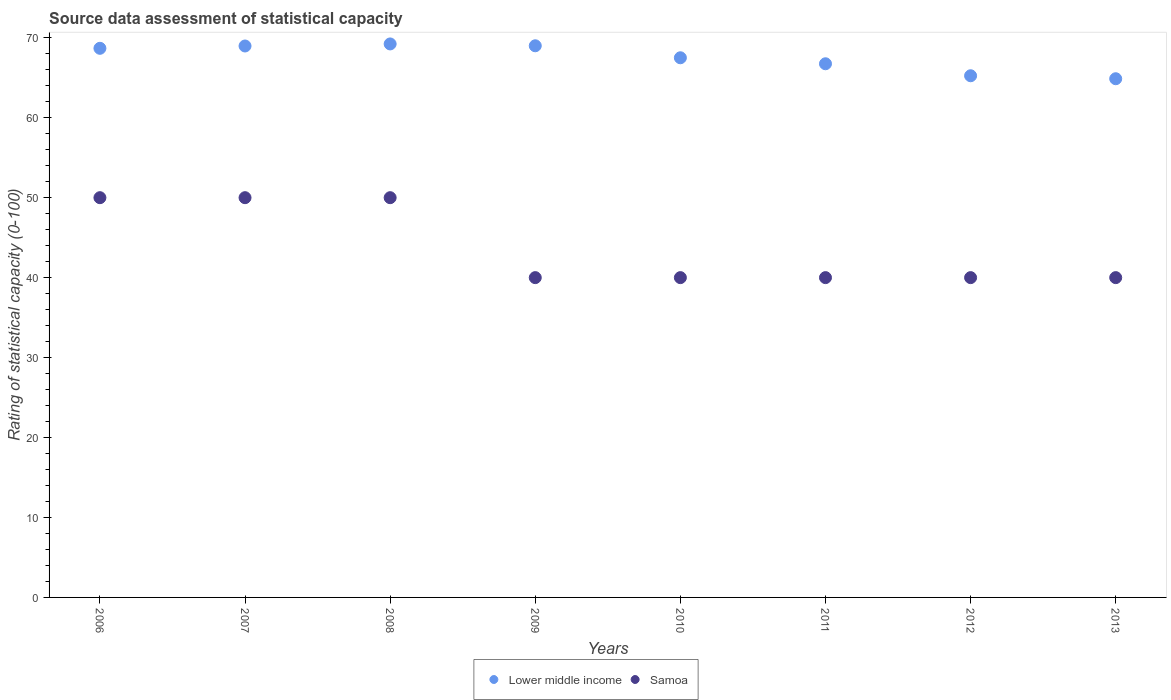Is the number of dotlines equal to the number of legend labels?
Offer a terse response. Yes. Across all years, what is the maximum rating of statistical capacity in Lower middle income?
Keep it short and to the point. 69.23. Across all years, what is the minimum rating of statistical capacity in Lower middle income?
Keep it short and to the point. 64.88. In which year was the rating of statistical capacity in Lower middle income maximum?
Provide a succinct answer. 2008. What is the total rating of statistical capacity in Lower middle income in the graph?
Ensure brevity in your answer.  540.27. What is the difference between the rating of statistical capacity in Lower middle income in 2011 and the rating of statistical capacity in Samoa in 2012?
Offer a terse response. 26.75. What is the average rating of statistical capacity in Lower middle income per year?
Give a very brief answer. 67.53. In how many years, is the rating of statistical capacity in Lower middle income greater than 46?
Give a very brief answer. 8. What is the difference between the highest and the second highest rating of statistical capacity in Lower middle income?
Provide a short and direct response. 0.23. What is the difference between the highest and the lowest rating of statistical capacity in Lower middle income?
Your answer should be very brief. 4.35. Does the rating of statistical capacity in Lower middle income monotonically increase over the years?
Your response must be concise. No. Is the rating of statistical capacity in Lower middle income strictly greater than the rating of statistical capacity in Samoa over the years?
Your answer should be compact. Yes. Is the rating of statistical capacity in Lower middle income strictly less than the rating of statistical capacity in Samoa over the years?
Make the answer very short. No. How many dotlines are there?
Make the answer very short. 2. How many years are there in the graph?
Make the answer very short. 8. What is the difference between two consecutive major ticks on the Y-axis?
Your response must be concise. 10. Are the values on the major ticks of Y-axis written in scientific E-notation?
Keep it short and to the point. No. Does the graph contain grids?
Your answer should be compact. No. How are the legend labels stacked?
Ensure brevity in your answer.  Horizontal. What is the title of the graph?
Your answer should be very brief. Source data assessment of statistical capacity. Does "Mozambique" appear as one of the legend labels in the graph?
Provide a short and direct response. No. What is the label or title of the X-axis?
Make the answer very short. Years. What is the label or title of the Y-axis?
Your answer should be compact. Rating of statistical capacity (0-100). What is the Rating of statistical capacity (0-100) of Lower middle income in 2006?
Make the answer very short. 68.68. What is the Rating of statistical capacity (0-100) of Samoa in 2006?
Provide a short and direct response. 50. What is the Rating of statistical capacity (0-100) in Lower middle income in 2007?
Ensure brevity in your answer.  68.97. What is the Rating of statistical capacity (0-100) in Samoa in 2007?
Your answer should be very brief. 50. What is the Rating of statistical capacity (0-100) in Lower middle income in 2008?
Make the answer very short. 69.23. What is the Rating of statistical capacity (0-100) in Samoa in 2008?
Give a very brief answer. 50. What is the Rating of statistical capacity (0-100) of Lower middle income in 2009?
Your response must be concise. 69. What is the Rating of statistical capacity (0-100) in Lower middle income in 2010?
Your response must be concise. 67.5. What is the Rating of statistical capacity (0-100) of Samoa in 2010?
Offer a very short reply. 40. What is the Rating of statistical capacity (0-100) in Lower middle income in 2011?
Give a very brief answer. 66.75. What is the Rating of statistical capacity (0-100) in Lower middle income in 2012?
Provide a short and direct response. 65.25. What is the Rating of statistical capacity (0-100) of Samoa in 2012?
Offer a terse response. 40. What is the Rating of statistical capacity (0-100) in Lower middle income in 2013?
Give a very brief answer. 64.88. What is the Rating of statistical capacity (0-100) of Samoa in 2013?
Provide a short and direct response. 40. Across all years, what is the maximum Rating of statistical capacity (0-100) of Lower middle income?
Give a very brief answer. 69.23. Across all years, what is the minimum Rating of statistical capacity (0-100) of Lower middle income?
Keep it short and to the point. 64.88. Across all years, what is the minimum Rating of statistical capacity (0-100) of Samoa?
Your response must be concise. 40. What is the total Rating of statistical capacity (0-100) in Lower middle income in the graph?
Give a very brief answer. 540.27. What is the total Rating of statistical capacity (0-100) in Samoa in the graph?
Keep it short and to the point. 350. What is the difference between the Rating of statistical capacity (0-100) in Lower middle income in 2006 and that in 2007?
Give a very brief answer. -0.29. What is the difference between the Rating of statistical capacity (0-100) of Samoa in 2006 and that in 2007?
Offer a terse response. 0. What is the difference between the Rating of statistical capacity (0-100) of Lower middle income in 2006 and that in 2008?
Ensure brevity in your answer.  -0.55. What is the difference between the Rating of statistical capacity (0-100) in Lower middle income in 2006 and that in 2009?
Offer a very short reply. -0.32. What is the difference between the Rating of statistical capacity (0-100) of Lower middle income in 2006 and that in 2010?
Keep it short and to the point. 1.18. What is the difference between the Rating of statistical capacity (0-100) in Lower middle income in 2006 and that in 2011?
Keep it short and to the point. 1.93. What is the difference between the Rating of statistical capacity (0-100) in Lower middle income in 2006 and that in 2012?
Your answer should be compact. 3.43. What is the difference between the Rating of statistical capacity (0-100) of Lower middle income in 2006 and that in 2013?
Offer a terse response. 3.81. What is the difference between the Rating of statistical capacity (0-100) of Lower middle income in 2007 and that in 2008?
Offer a terse response. -0.26. What is the difference between the Rating of statistical capacity (0-100) in Lower middle income in 2007 and that in 2009?
Keep it short and to the point. -0.03. What is the difference between the Rating of statistical capacity (0-100) of Samoa in 2007 and that in 2009?
Your answer should be very brief. 10. What is the difference between the Rating of statistical capacity (0-100) in Lower middle income in 2007 and that in 2010?
Your answer should be very brief. 1.47. What is the difference between the Rating of statistical capacity (0-100) in Samoa in 2007 and that in 2010?
Provide a succinct answer. 10. What is the difference between the Rating of statistical capacity (0-100) in Lower middle income in 2007 and that in 2011?
Keep it short and to the point. 2.22. What is the difference between the Rating of statistical capacity (0-100) in Samoa in 2007 and that in 2011?
Keep it short and to the point. 10. What is the difference between the Rating of statistical capacity (0-100) in Lower middle income in 2007 and that in 2012?
Your answer should be compact. 3.72. What is the difference between the Rating of statistical capacity (0-100) of Samoa in 2007 and that in 2012?
Your answer should be compact. 10. What is the difference between the Rating of statistical capacity (0-100) in Lower middle income in 2007 and that in 2013?
Provide a succinct answer. 4.1. What is the difference between the Rating of statistical capacity (0-100) of Samoa in 2007 and that in 2013?
Provide a short and direct response. 10. What is the difference between the Rating of statistical capacity (0-100) of Lower middle income in 2008 and that in 2009?
Give a very brief answer. 0.23. What is the difference between the Rating of statistical capacity (0-100) of Lower middle income in 2008 and that in 2010?
Provide a short and direct response. 1.73. What is the difference between the Rating of statistical capacity (0-100) of Lower middle income in 2008 and that in 2011?
Your response must be concise. 2.48. What is the difference between the Rating of statistical capacity (0-100) of Lower middle income in 2008 and that in 2012?
Provide a short and direct response. 3.98. What is the difference between the Rating of statistical capacity (0-100) of Samoa in 2008 and that in 2012?
Offer a very short reply. 10. What is the difference between the Rating of statistical capacity (0-100) in Lower middle income in 2008 and that in 2013?
Ensure brevity in your answer.  4.35. What is the difference between the Rating of statistical capacity (0-100) in Samoa in 2008 and that in 2013?
Provide a short and direct response. 10. What is the difference between the Rating of statistical capacity (0-100) in Samoa in 2009 and that in 2010?
Your response must be concise. 0. What is the difference between the Rating of statistical capacity (0-100) in Lower middle income in 2009 and that in 2011?
Your response must be concise. 2.25. What is the difference between the Rating of statistical capacity (0-100) in Samoa in 2009 and that in 2011?
Keep it short and to the point. 0. What is the difference between the Rating of statistical capacity (0-100) in Lower middle income in 2009 and that in 2012?
Keep it short and to the point. 3.75. What is the difference between the Rating of statistical capacity (0-100) in Lower middle income in 2009 and that in 2013?
Provide a succinct answer. 4.12. What is the difference between the Rating of statistical capacity (0-100) of Samoa in 2009 and that in 2013?
Offer a terse response. 0. What is the difference between the Rating of statistical capacity (0-100) of Lower middle income in 2010 and that in 2011?
Your response must be concise. 0.75. What is the difference between the Rating of statistical capacity (0-100) in Samoa in 2010 and that in 2011?
Offer a terse response. 0. What is the difference between the Rating of statistical capacity (0-100) in Lower middle income in 2010 and that in 2012?
Offer a very short reply. 2.25. What is the difference between the Rating of statistical capacity (0-100) of Samoa in 2010 and that in 2012?
Provide a short and direct response. 0. What is the difference between the Rating of statistical capacity (0-100) of Lower middle income in 2010 and that in 2013?
Offer a terse response. 2.62. What is the difference between the Rating of statistical capacity (0-100) of Samoa in 2011 and that in 2012?
Offer a very short reply. 0. What is the difference between the Rating of statistical capacity (0-100) of Lower middle income in 2011 and that in 2013?
Give a very brief answer. 1.87. What is the difference between the Rating of statistical capacity (0-100) in Lower middle income in 2012 and that in 2013?
Offer a terse response. 0.37. What is the difference between the Rating of statistical capacity (0-100) of Samoa in 2012 and that in 2013?
Keep it short and to the point. 0. What is the difference between the Rating of statistical capacity (0-100) of Lower middle income in 2006 and the Rating of statistical capacity (0-100) of Samoa in 2007?
Keep it short and to the point. 18.68. What is the difference between the Rating of statistical capacity (0-100) in Lower middle income in 2006 and the Rating of statistical capacity (0-100) in Samoa in 2008?
Give a very brief answer. 18.68. What is the difference between the Rating of statistical capacity (0-100) of Lower middle income in 2006 and the Rating of statistical capacity (0-100) of Samoa in 2009?
Make the answer very short. 28.68. What is the difference between the Rating of statistical capacity (0-100) of Lower middle income in 2006 and the Rating of statistical capacity (0-100) of Samoa in 2010?
Your answer should be compact. 28.68. What is the difference between the Rating of statistical capacity (0-100) of Lower middle income in 2006 and the Rating of statistical capacity (0-100) of Samoa in 2011?
Give a very brief answer. 28.68. What is the difference between the Rating of statistical capacity (0-100) in Lower middle income in 2006 and the Rating of statistical capacity (0-100) in Samoa in 2012?
Give a very brief answer. 28.68. What is the difference between the Rating of statistical capacity (0-100) in Lower middle income in 2006 and the Rating of statistical capacity (0-100) in Samoa in 2013?
Give a very brief answer. 28.68. What is the difference between the Rating of statistical capacity (0-100) of Lower middle income in 2007 and the Rating of statistical capacity (0-100) of Samoa in 2008?
Your response must be concise. 18.97. What is the difference between the Rating of statistical capacity (0-100) in Lower middle income in 2007 and the Rating of statistical capacity (0-100) in Samoa in 2009?
Your answer should be compact. 28.97. What is the difference between the Rating of statistical capacity (0-100) of Lower middle income in 2007 and the Rating of statistical capacity (0-100) of Samoa in 2010?
Keep it short and to the point. 28.97. What is the difference between the Rating of statistical capacity (0-100) in Lower middle income in 2007 and the Rating of statistical capacity (0-100) in Samoa in 2011?
Give a very brief answer. 28.97. What is the difference between the Rating of statistical capacity (0-100) in Lower middle income in 2007 and the Rating of statistical capacity (0-100) in Samoa in 2012?
Offer a very short reply. 28.97. What is the difference between the Rating of statistical capacity (0-100) of Lower middle income in 2007 and the Rating of statistical capacity (0-100) of Samoa in 2013?
Your answer should be compact. 28.97. What is the difference between the Rating of statistical capacity (0-100) in Lower middle income in 2008 and the Rating of statistical capacity (0-100) in Samoa in 2009?
Your response must be concise. 29.23. What is the difference between the Rating of statistical capacity (0-100) in Lower middle income in 2008 and the Rating of statistical capacity (0-100) in Samoa in 2010?
Make the answer very short. 29.23. What is the difference between the Rating of statistical capacity (0-100) in Lower middle income in 2008 and the Rating of statistical capacity (0-100) in Samoa in 2011?
Ensure brevity in your answer.  29.23. What is the difference between the Rating of statistical capacity (0-100) of Lower middle income in 2008 and the Rating of statistical capacity (0-100) of Samoa in 2012?
Keep it short and to the point. 29.23. What is the difference between the Rating of statistical capacity (0-100) of Lower middle income in 2008 and the Rating of statistical capacity (0-100) of Samoa in 2013?
Provide a succinct answer. 29.23. What is the difference between the Rating of statistical capacity (0-100) of Lower middle income in 2009 and the Rating of statistical capacity (0-100) of Samoa in 2011?
Keep it short and to the point. 29. What is the difference between the Rating of statistical capacity (0-100) in Lower middle income in 2009 and the Rating of statistical capacity (0-100) in Samoa in 2012?
Provide a succinct answer. 29. What is the difference between the Rating of statistical capacity (0-100) of Lower middle income in 2010 and the Rating of statistical capacity (0-100) of Samoa in 2012?
Provide a short and direct response. 27.5. What is the difference between the Rating of statistical capacity (0-100) of Lower middle income in 2011 and the Rating of statistical capacity (0-100) of Samoa in 2012?
Offer a very short reply. 26.75. What is the difference between the Rating of statistical capacity (0-100) of Lower middle income in 2011 and the Rating of statistical capacity (0-100) of Samoa in 2013?
Your answer should be very brief. 26.75. What is the difference between the Rating of statistical capacity (0-100) in Lower middle income in 2012 and the Rating of statistical capacity (0-100) in Samoa in 2013?
Provide a short and direct response. 25.25. What is the average Rating of statistical capacity (0-100) of Lower middle income per year?
Provide a short and direct response. 67.53. What is the average Rating of statistical capacity (0-100) of Samoa per year?
Offer a very short reply. 43.75. In the year 2006, what is the difference between the Rating of statistical capacity (0-100) in Lower middle income and Rating of statistical capacity (0-100) in Samoa?
Your answer should be compact. 18.68. In the year 2007, what is the difference between the Rating of statistical capacity (0-100) in Lower middle income and Rating of statistical capacity (0-100) in Samoa?
Your answer should be compact. 18.97. In the year 2008, what is the difference between the Rating of statistical capacity (0-100) of Lower middle income and Rating of statistical capacity (0-100) of Samoa?
Your answer should be very brief. 19.23. In the year 2009, what is the difference between the Rating of statistical capacity (0-100) in Lower middle income and Rating of statistical capacity (0-100) in Samoa?
Your answer should be very brief. 29. In the year 2011, what is the difference between the Rating of statistical capacity (0-100) in Lower middle income and Rating of statistical capacity (0-100) in Samoa?
Provide a short and direct response. 26.75. In the year 2012, what is the difference between the Rating of statistical capacity (0-100) in Lower middle income and Rating of statistical capacity (0-100) in Samoa?
Your answer should be very brief. 25.25. In the year 2013, what is the difference between the Rating of statistical capacity (0-100) in Lower middle income and Rating of statistical capacity (0-100) in Samoa?
Offer a terse response. 24.88. What is the ratio of the Rating of statistical capacity (0-100) in Samoa in 2006 to that in 2008?
Give a very brief answer. 1. What is the ratio of the Rating of statistical capacity (0-100) of Lower middle income in 2006 to that in 2010?
Offer a terse response. 1.02. What is the ratio of the Rating of statistical capacity (0-100) of Samoa in 2006 to that in 2010?
Make the answer very short. 1.25. What is the ratio of the Rating of statistical capacity (0-100) of Samoa in 2006 to that in 2011?
Provide a succinct answer. 1.25. What is the ratio of the Rating of statistical capacity (0-100) in Lower middle income in 2006 to that in 2012?
Ensure brevity in your answer.  1.05. What is the ratio of the Rating of statistical capacity (0-100) of Samoa in 2006 to that in 2012?
Provide a succinct answer. 1.25. What is the ratio of the Rating of statistical capacity (0-100) in Lower middle income in 2006 to that in 2013?
Offer a terse response. 1.06. What is the ratio of the Rating of statistical capacity (0-100) in Lower middle income in 2007 to that in 2010?
Ensure brevity in your answer.  1.02. What is the ratio of the Rating of statistical capacity (0-100) of Lower middle income in 2007 to that in 2011?
Ensure brevity in your answer.  1.03. What is the ratio of the Rating of statistical capacity (0-100) in Samoa in 2007 to that in 2011?
Your answer should be compact. 1.25. What is the ratio of the Rating of statistical capacity (0-100) in Lower middle income in 2007 to that in 2012?
Ensure brevity in your answer.  1.06. What is the ratio of the Rating of statistical capacity (0-100) in Lower middle income in 2007 to that in 2013?
Your answer should be very brief. 1.06. What is the ratio of the Rating of statistical capacity (0-100) of Lower middle income in 2008 to that in 2010?
Your answer should be compact. 1.03. What is the ratio of the Rating of statistical capacity (0-100) of Samoa in 2008 to that in 2010?
Keep it short and to the point. 1.25. What is the ratio of the Rating of statistical capacity (0-100) of Lower middle income in 2008 to that in 2011?
Offer a very short reply. 1.04. What is the ratio of the Rating of statistical capacity (0-100) of Samoa in 2008 to that in 2011?
Offer a terse response. 1.25. What is the ratio of the Rating of statistical capacity (0-100) in Lower middle income in 2008 to that in 2012?
Your answer should be compact. 1.06. What is the ratio of the Rating of statistical capacity (0-100) of Samoa in 2008 to that in 2012?
Make the answer very short. 1.25. What is the ratio of the Rating of statistical capacity (0-100) in Lower middle income in 2008 to that in 2013?
Provide a short and direct response. 1.07. What is the ratio of the Rating of statistical capacity (0-100) in Samoa in 2008 to that in 2013?
Your answer should be very brief. 1.25. What is the ratio of the Rating of statistical capacity (0-100) of Lower middle income in 2009 to that in 2010?
Give a very brief answer. 1.02. What is the ratio of the Rating of statistical capacity (0-100) of Lower middle income in 2009 to that in 2011?
Your answer should be compact. 1.03. What is the ratio of the Rating of statistical capacity (0-100) of Lower middle income in 2009 to that in 2012?
Offer a terse response. 1.06. What is the ratio of the Rating of statistical capacity (0-100) of Samoa in 2009 to that in 2012?
Your answer should be very brief. 1. What is the ratio of the Rating of statistical capacity (0-100) in Lower middle income in 2009 to that in 2013?
Give a very brief answer. 1.06. What is the ratio of the Rating of statistical capacity (0-100) of Samoa in 2009 to that in 2013?
Keep it short and to the point. 1. What is the ratio of the Rating of statistical capacity (0-100) in Lower middle income in 2010 to that in 2011?
Ensure brevity in your answer.  1.01. What is the ratio of the Rating of statistical capacity (0-100) of Samoa in 2010 to that in 2011?
Provide a short and direct response. 1. What is the ratio of the Rating of statistical capacity (0-100) in Lower middle income in 2010 to that in 2012?
Your response must be concise. 1.03. What is the ratio of the Rating of statistical capacity (0-100) of Lower middle income in 2010 to that in 2013?
Give a very brief answer. 1.04. What is the ratio of the Rating of statistical capacity (0-100) in Lower middle income in 2011 to that in 2013?
Your answer should be compact. 1.03. What is the difference between the highest and the second highest Rating of statistical capacity (0-100) of Lower middle income?
Your answer should be compact. 0.23. What is the difference between the highest and the lowest Rating of statistical capacity (0-100) of Lower middle income?
Offer a terse response. 4.35. 